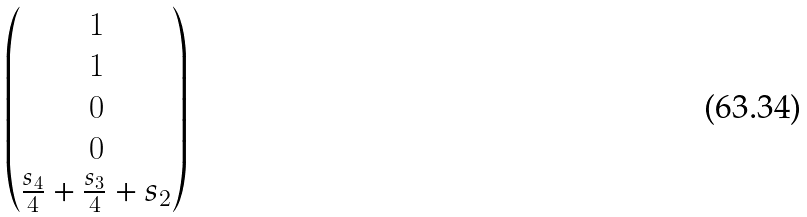<formula> <loc_0><loc_0><loc_500><loc_500>\begin{pmatrix} 1 \\ 1 \\ 0 \\ 0 \\ \frac { s _ { 4 } } { 4 } + \frac { s _ { 3 } } { 4 } + s _ { 2 } \end{pmatrix}</formula> 